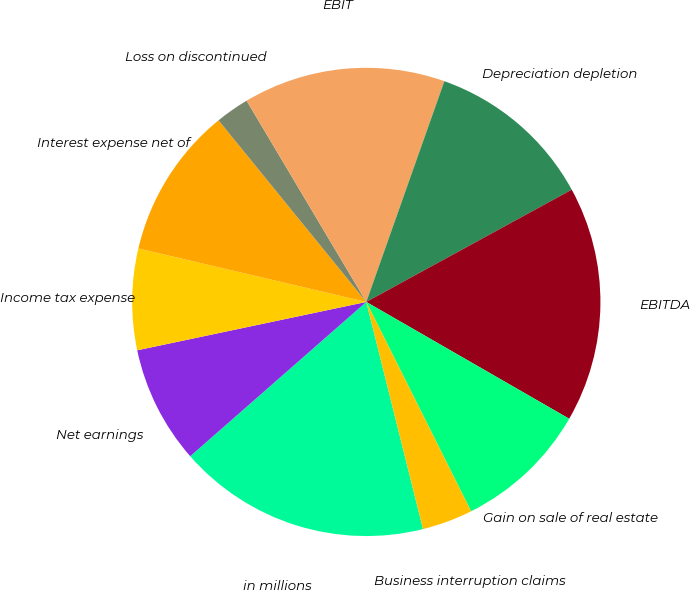Convert chart to OTSL. <chart><loc_0><loc_0><loc_500><loc_500><pie_chart><fcel>in millions<fcel>Net earnings<fcel>Income tax expense<fcel>Interest expense net of<fcel>Loss on discontinued<fcel>EBIT<fcel>Depreciation depletion<fcel>EBITDA<fcel>Gain on sale of real estate<fcel>Business interruption claims<nl><fcel>17.44%<fcel>8.14%<fcel>6.98%<fcel>10.46%<fcel>2.33%<fcel>13.95%<fcel>11.63%<fcel>16.27%<fcel>9.3%<fcel>3.49%<nl></chart> 